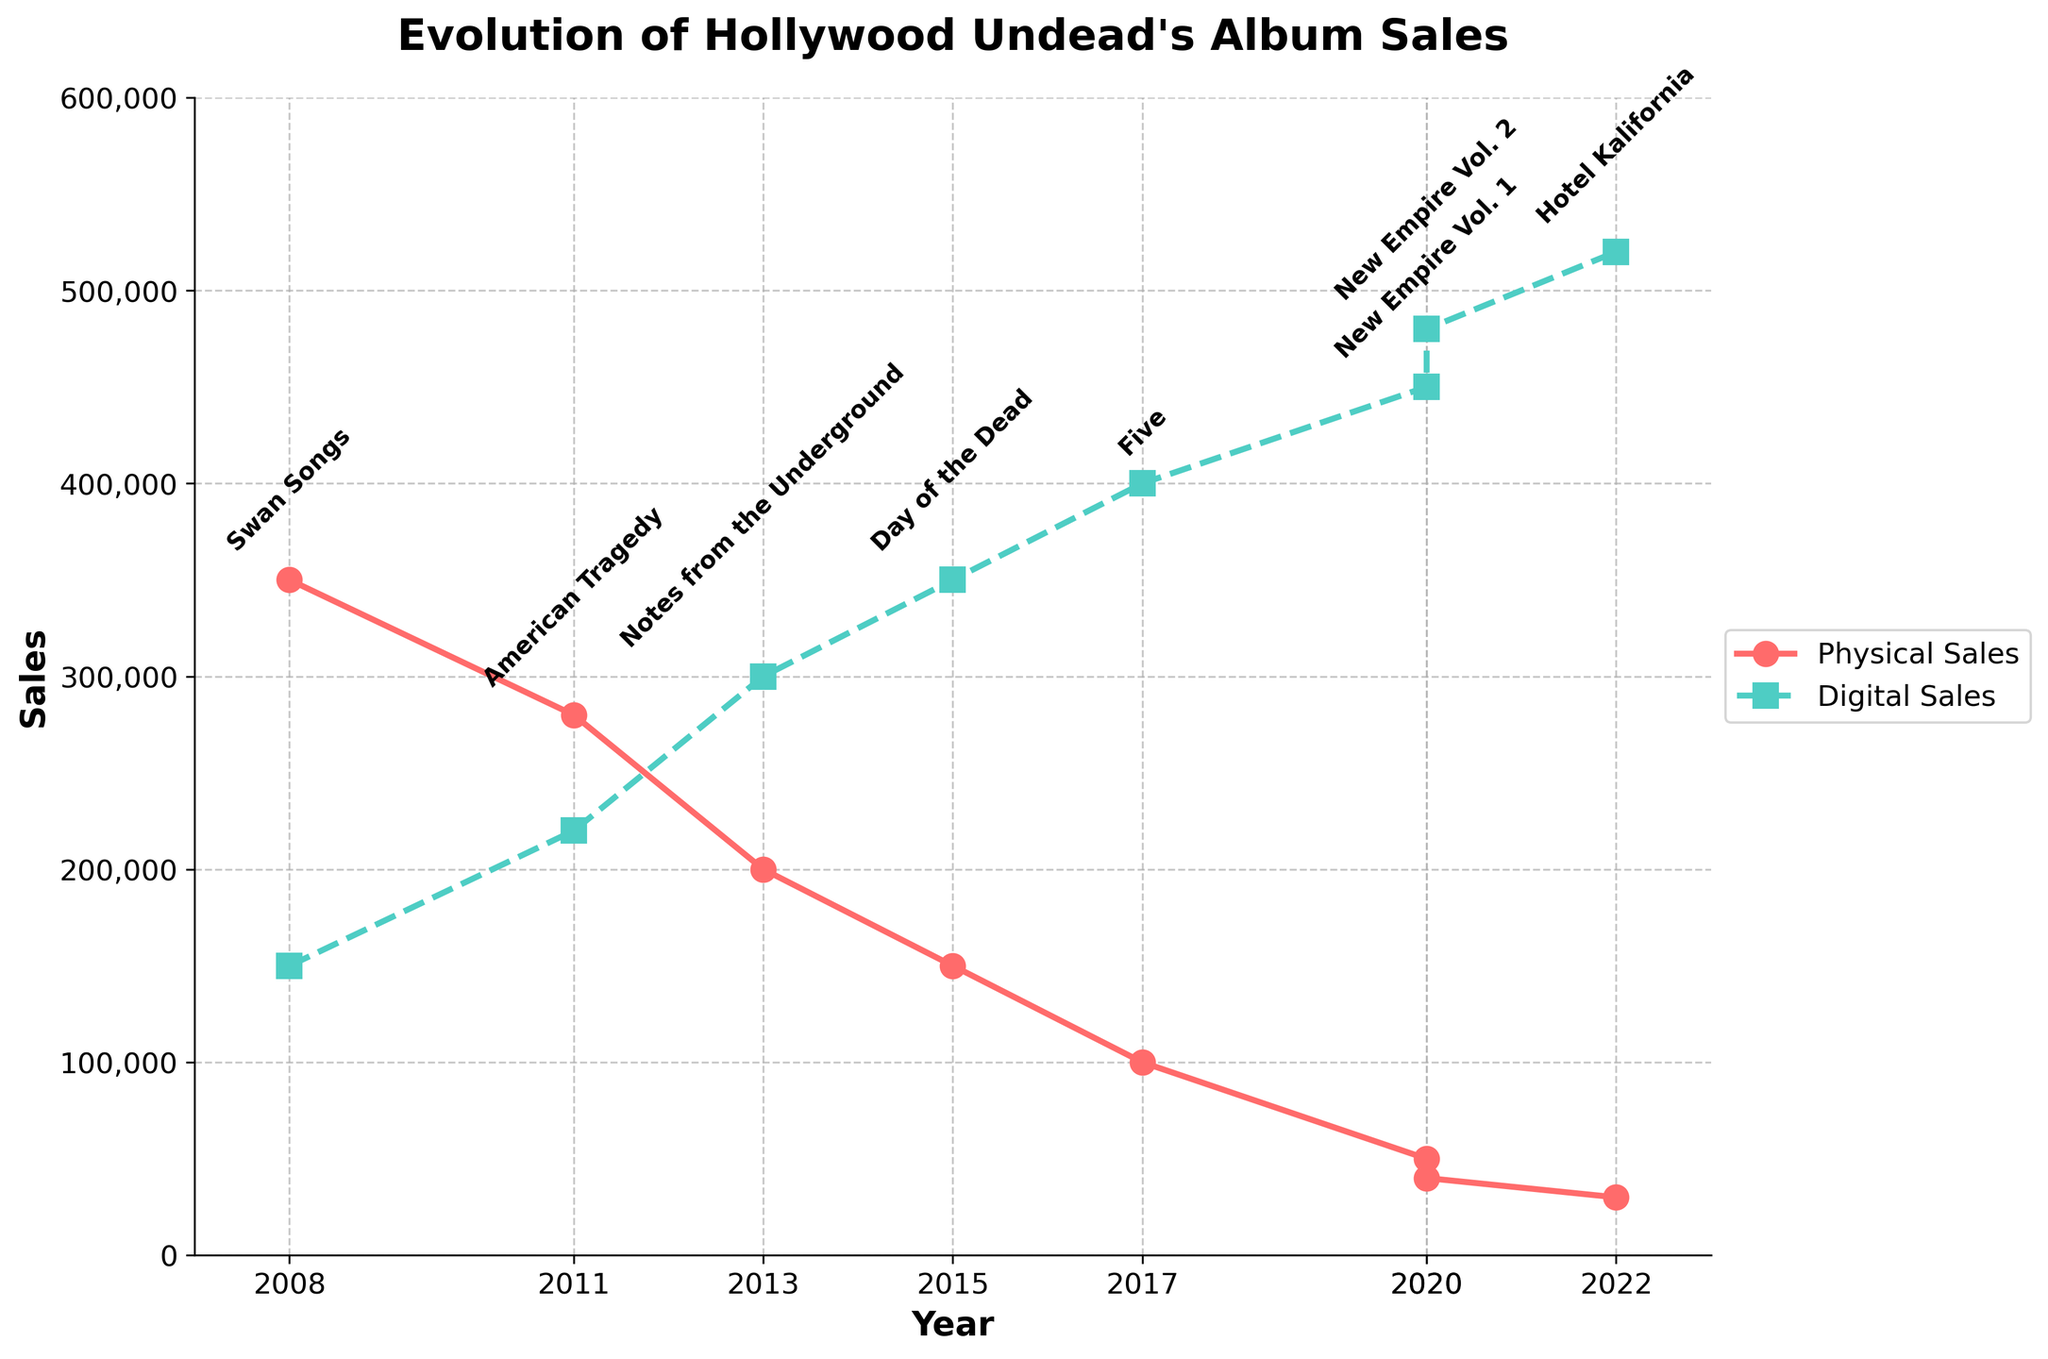What is the difference in digital sales between "American Tragedy" and "Five"? "American Tragedy" digital sales are 220,000 and "Five" digital sales are 400,000. The difference is 400,000 - 220,000.
Answer: 180,000 How many years did it take for physical sales to drop from 350,000 to 30,000? Physical sales of 350,000 were seen in 2008 ("Swan Songs") and the lowest 30,000 were in 2022 ("Hotel Kalifornia"). The difference in years is 2022 - 2008.
Answer: 14 years Which album had the highest digital sales and what were the sales? By looking at the highest point on the green dashed line, "Hotel Kalifornia" in 2022 had the highest digital sales with 520,000.
Answer: Hotel Kalifornia, 520,000 In which year did physical sales first become lower than digital sales? By looking at the intersection of the red solid line and the green dashed line, 2013 ("Notes from the Underground") was the year when physical sales (200,000) first became lower than digital sales (300,000).
Answer: 2013 What is the average digital sales across all albums? Sum all digital sales: 150,000 + 220,000 + 300,000 + 350,000 + 400,000 + 450,000 + 480,000 + 520,000 = 2,870,000. There are 8 albums. So, the average is 2,870,000 / 8.
Answer: 358,750 Which album had the closest physical sales and digital sales values and what are those values? Compare the difference between physical and digital sales for each album. "Notes from the Underground" in 2013 had 200,000 physical sales and 300,000 digital sales. The difference is 300,000 - 200,000 = 100,000, which is the smallest difference among all albums.
Answer: Notes from the Underground, Physical: 200,000, Digital: 300,000 What is the trend observed in physical sales from 2008 to 2022? From 2008 till 2022, the red solid line representing physical sales shows a consistent decreasing trend from 350,000 to 30,000.
Answer: Decreasing If both physical and digital sales in 2020 are combined, which year had the highest total sales and what was the total? Sum of physical and digital sales in 2020: (50,000 + 450,000) and (40,000 + 480,000) equals 940,000. Sum sales for other years and compare: 500,000 (2008), 500,000 (2011), 500,000 (2013), 500,000 (2015), 500,000 (2017), and 550,000 (2022). None exceed 2020's combined 940,000.
Answer: 2020, 940,000 